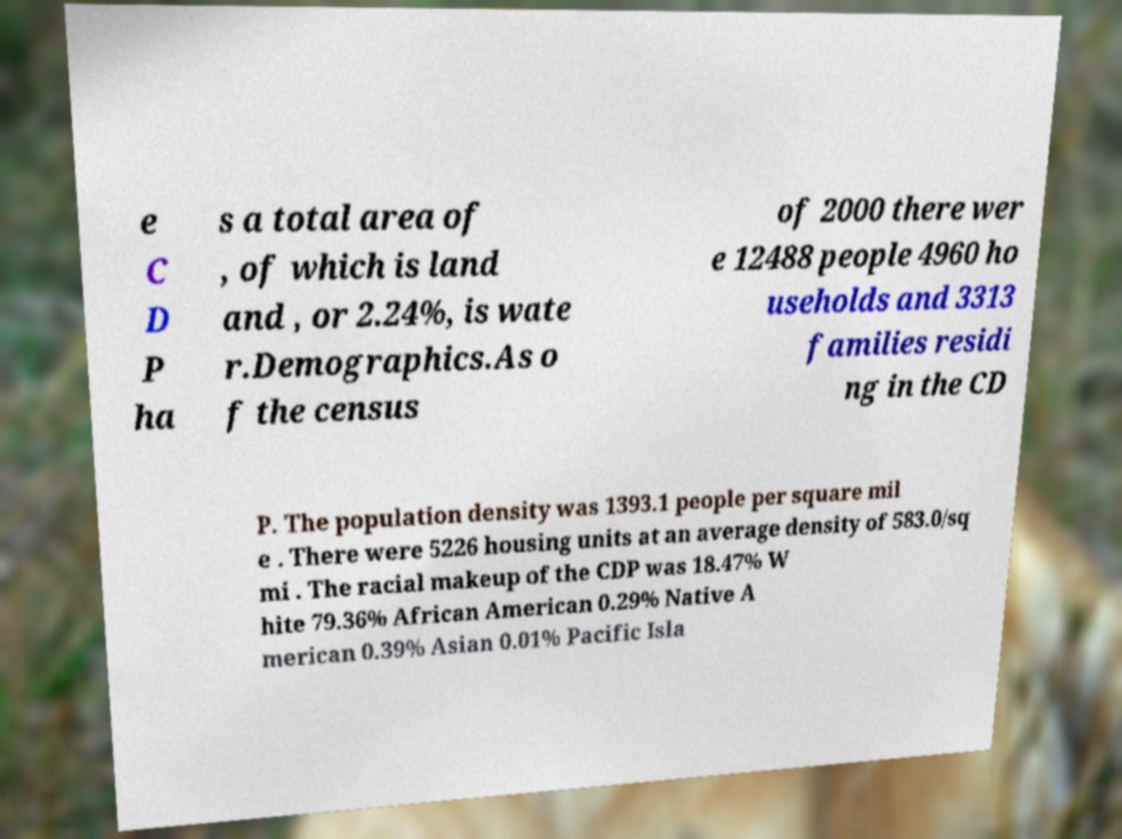What messages or text are displayed in this image? I need them in a readable, typed format. e C D P ha s a total area of , of which is land and , or 2.24%, is wate r.Demographics.As o f the census of 2000 there wer e 12488 people 4960 ho useholds and 3313 families residi ng in the CD P. The population density was 1393.1 people per square mil e . There were 5226 housing units at an average density of 583.0/sq mi . The racial makeup of the CDP was 18.47% W hite 79.36% African American 0.29% Native A merican 0.39% Asian 0.01% Pacific Isla 